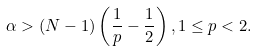Convert formula to latex. <formula><loc_0><loc_0><loc_500><loc_500>\alpha > ( N - 1 ) \left ( \frac { 1 } { p } - \frac { 1 } { 2 } \right ) , 1 \leq p < 2 .</formula> 